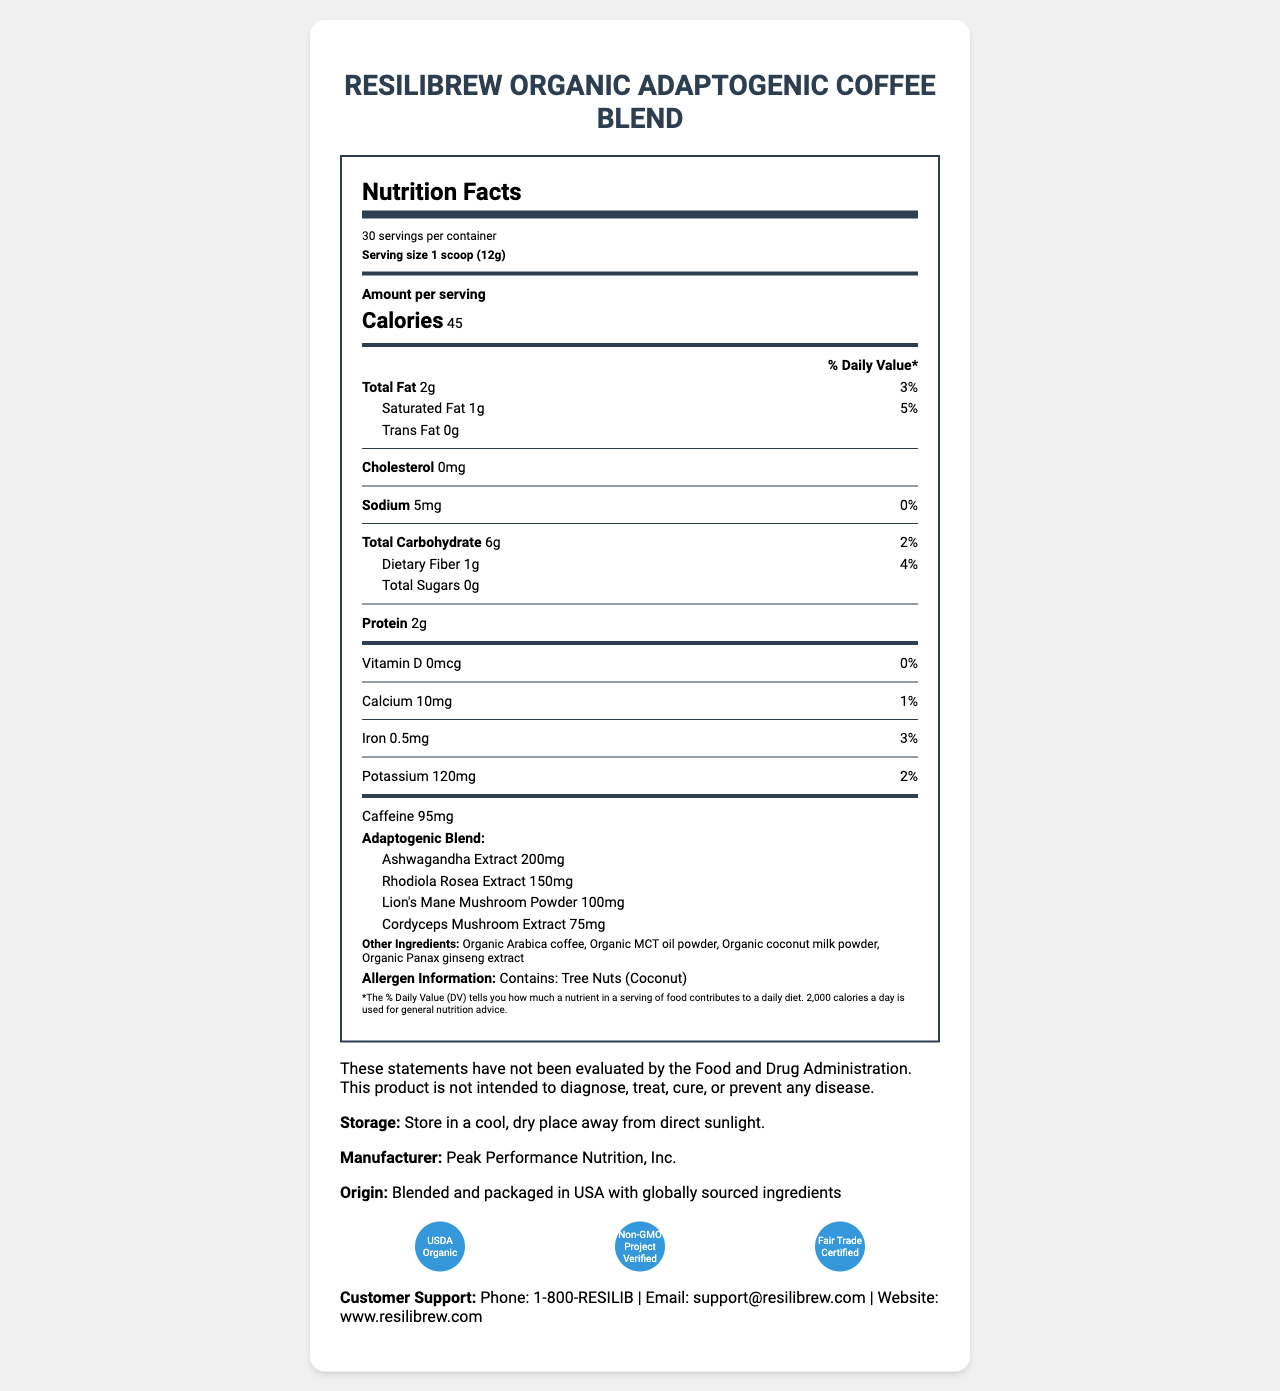what is the serving size? The serving size is listed as "1 scoop (12g)" under the product name.
Answer: 1 scoop (12g) how many servings per container are there? The document states "30 servings per container" in the nutrition label section.
Answer: 30 how many calories are in one serving? The nutrition label specifies that there are 45 calories per serving.
Answer: 45 what is the total fat content per serving? The nutrition label lists "Total Fat" as 2g for each serving.
Answer: 2g what is the amount of dietary fiber in each serving? The dietary fiber amount is listed as 1g per serving in the nutrition label.
Answer: 1g how much ashwagandha extract is included in the adaptogenic blend? The adaptogenic blend section specifies that there are 200mg of ashwagandha extract per serving.
Answer: 200mg does the product contain any cholesterol? The nutrition label explicitly states "Cholesterol 0mg," indicating that there is no cholesterol.
Answer: No which certifications does the product have? A. USDA Organic, Non-GMO Project Verified, Fair Trade Certified B. USDA Organic, Fair Trade Certified, Gluten-Free Certified C. USDA Organic, Non-GMO Project Verified, Kosher Certified The certifications section lists "USDA Organic," "Non-GMO Project Verified," and "Fair Trade Certified."
Answer: A what is the amount of caffeine per serving? The nutrition label specifies that there are 95mg of caffeine per serving.
Answer: 95mg is the product intended to diagnose or treat diseases according to the disclaimer? The disclaimer clearly states, "This product is not intended to diagnose, treat, cure, or prevent any disease."
Answer: No what is the storage instruction for the product? The document advises storing the product "in a cool, dry place away from direct sunlight" under the storage section.
Answer: Store in a cool, dry place away from direct sunlight. where is the product blended and packaged? The origin section states "Blended and packaged in USA with globally sourced ingredients."
Answer: USA what are the main adaptogens included in the blend? The adaptogenic blend section lists the main adaptogens as "Ashwagandha extract, Rhodiola Rosea extract, Lion's Mane mushroom powder, and Cordyceps mushroom extract."
Answer: Ashwagandha extract, Rhodiola Rosea extract, Lion's Mane mushroom powder, Cordyceps mushroom extract summarize the key nutritional and ingredient information for this product. The summary covers all key nutritional aspects, including calories, major nutrients, adaptogens, and certifications.
Answer: ResiliBrew Organic Adaptogenic Coffee Blend provides 45 calories per 1 scoop (12g) serving, with key nutrients including 2g of total fat, 6g of total carbohydrate, 1g of dietary fiber, and 2g of protein. It contains no cholesterol and minimal sodium. The product is rich in caffeine (95mg per serving) and includes adaptogenic ingredients like ashwagandha extract (200mg), Rhodiola Rosea extract (150mg), Lion's Mane mushroom powder (100mg), and Cordyceps mushroom extract (75mg). Additionally, it is USDA Organic, Non-GMO Project Verified, and Fair Trade Certified. does the nutrition label mention dietary fiber? The nutritional label includes "Dietary Fiber 1g."
Answer: Yes how many other ingredients are listed in the product? The document lists four other ingredients: "Organic Arabica coffee, Organic MCT oil powder, Organic coconut milk powder, Organic Panax ginseng extract."
Answer: Four what is the contact email for customer support? The customer support section provides the email address "support@resilibrew.com."
Answer: support@resilibrew.com how should one contact customer support by phone? The document lists "1-800-RESILIB" as the phone number for customer support.
Answer: Call 1-800-RESILIB what is the iron content per serving as a percentage of daily value? The nutrition label states that the iron content per serving is 0.5mg, which is 3% of the daily value.
Answer: 3% how much Vitamin D is in each serving? A. 0mcg B. 1mcg C. 5mcg The nutritional information indicates that there is 0mcg of Vitamin D per serving.
Answer: A how is the product certified regarding non-GMO status? The document includes a certification for "Non-GMO Project Verified."
Answer: Non-GMO Project Verified are there any added sugars in this product? The nutrition label clearly states "Total Sugars 0g," indicating there are no added sugars.
Answer: No who manufactures this product? The manufacturer section states that the product is made by "Peak Performance Nutrition, Inc."
Answer: Peak Performance Nutrition, Inc. who sources the ingredients for this product? The document states the product is blended and packaged in the USA with globally sourced ingredients, but it does not specify who sources them.
Answer: Cannot be determined 